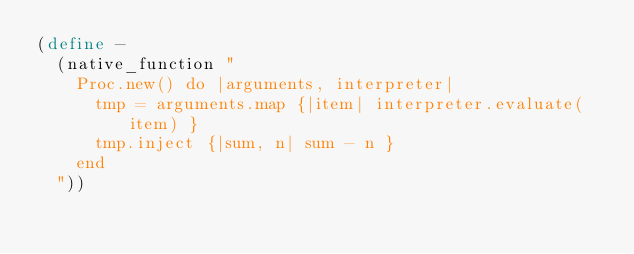Convert code to text. <code><loc_0><loc_0><loc_500><loc_500><_Scheme_>(define -
  (native_function "
    Proc.new() do |arguments, interpreter|
      tmp = arguments.map {|item| interpreter.evaluate(item) }
      tmp.inject {|sum, n| sum - n }
    end
  "))</code> 